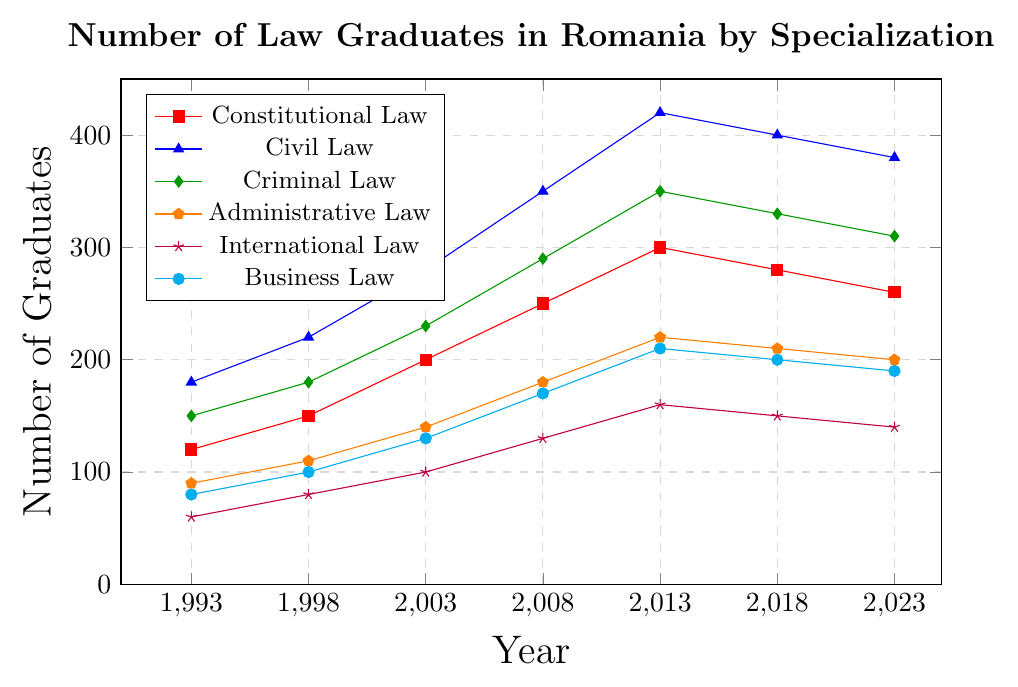What specialization had the highest number of graduates in 2013? From the figure, identify the point in 2013 with the highest y-value. The highest y-value in 2013 corresponds to Civil Law.
Answer: Civil Law Compare the trend of graduates in Constitutional Law and Criminal Law from 1993 to 2023. Which specialization had a steeper increase? Calculate the change for both specializations from 1993 to 2023. Constitutional Law changed from 120 to 260 (140 increase), while Criminal Law changed from 150 to 310 (160 increase). Thus, Criminal Law had a steeper increase.
Answer: Criminal Law What was the total number of graduates in all specializations in 2008? Sum the values of all specializations in 2008: 250 + 350 + 290 + 180 + 130 + 170. The total is 1370.
Answer: 1370 Which specialization saw the greatest decline in the number of graduates between 2013 and 2023? Compare the values of each specialization between 2013 and 2023 to see the decline. Constitutional Law declined from 300 to 260, Civil Law from 420 to 380, Criminal Law from 350 to 310, Administrative Law from 220 to 200, International Law from 160 to 140, and Business Law from 210 to 190. Constitutional Law saw the greatest decline (40).
Answer: Constitutional Law Which specialization consistently had the lowest number of graduates over the 30-year period? By visually scanning the lines, note that International Law consistently stays closer to the y-axis than the others across all years.
Answer: International Law What is the average number of graduates in Business Law from 1993 to 2023? Sum the number of Business Law graduates over the period and divide by the number of data points. (80 + 100 + 130 + 170 + 210 + 200 + 190) / 7 = 152.86.
Answer: 152.86 Between which two consecutive years did Constitutional Law see the largest increase in graduates? Calculate the differences between consecutive years: 30 (1993-1998), 50 (1998-2003), 50 (2003-2008), 50 (2008-2013), -20 (2013-2018), -20 (2018-2023). The largest increases are 50 between the years 1998-2003, 2003-2008, and 2008-2013.
Answer: 1998-2003, 2003-2008, 2008-2013 Which year had the least total number of graduates across all specializations? Sum the values for each year and find the minimal total: 680 (1993), 840 (1998), 1180 (2003), 1370 (2008), 1660 (2013), 1570 (2018), 1480 (2023). The least total number of graduates was in 1993.
Answer: 1993 